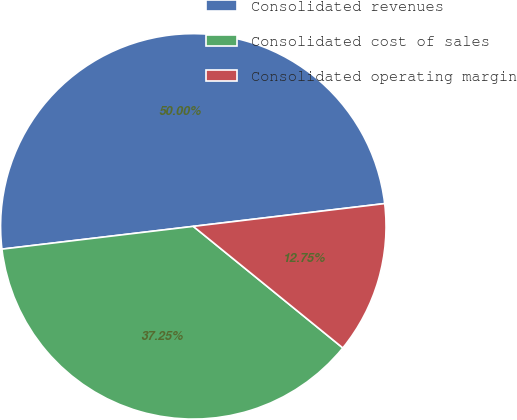<chart> <loc_0><loc_0><loc_500><loc_500><pie_chart><fcel>Consolidated revenues<fcel>Consolidated cost of sales<fcel>Consolidated operating margin<nl><fcel>50.0%<fcel>37.25%<fcel>12.75%<nl></chart> 